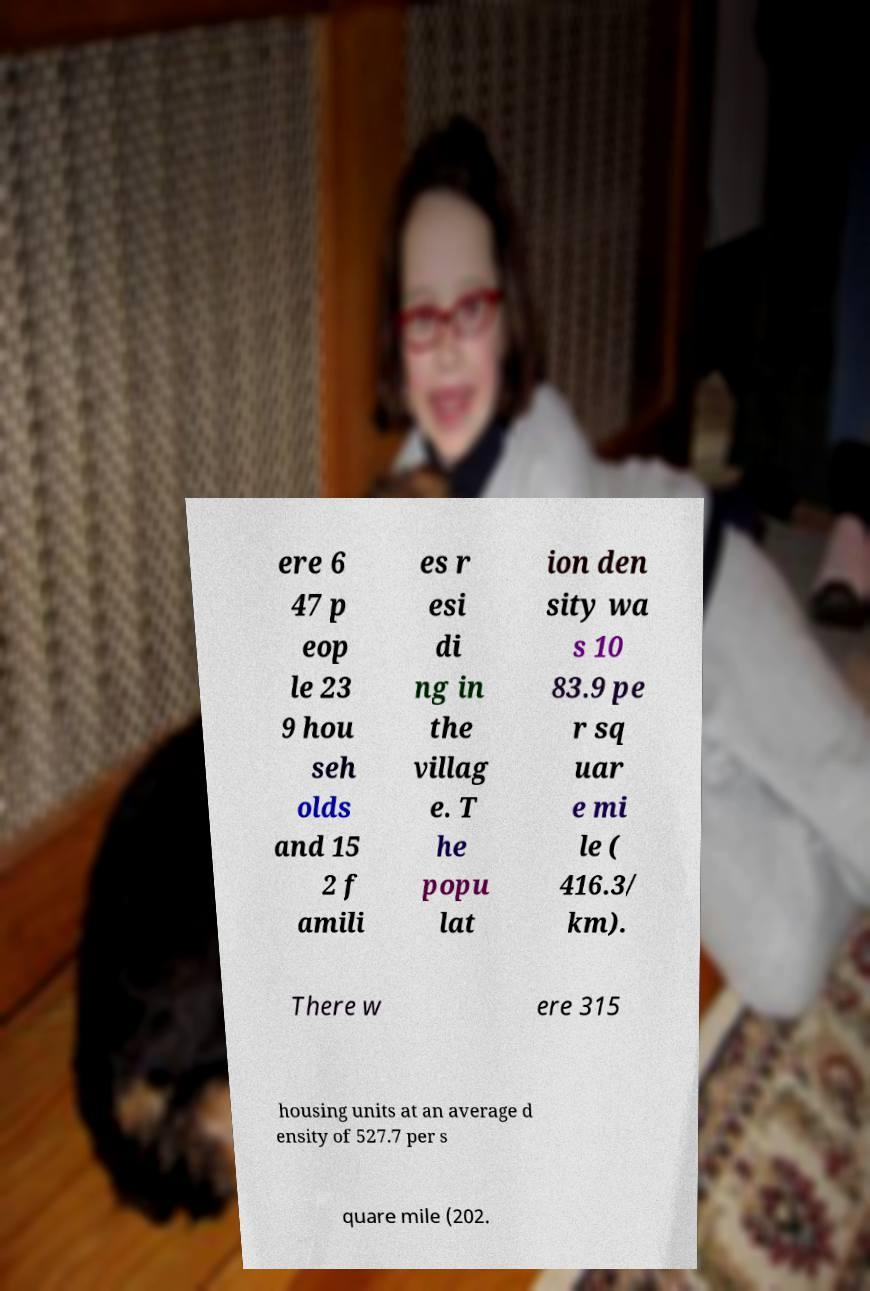What messages or text are displayed in this image? I need them in a readable, typed format. ere 6 47 p eop le 23 9 hou seh olds and 15 2 f amili es r esi di ng in the villag e. T he popu lat ion den sity wa s 10 83.9 pe r sq uar e mi le ( 416.3/ km). There w ere 315 housing units at an average d ensity of 527.7 per s quare mile (202. 